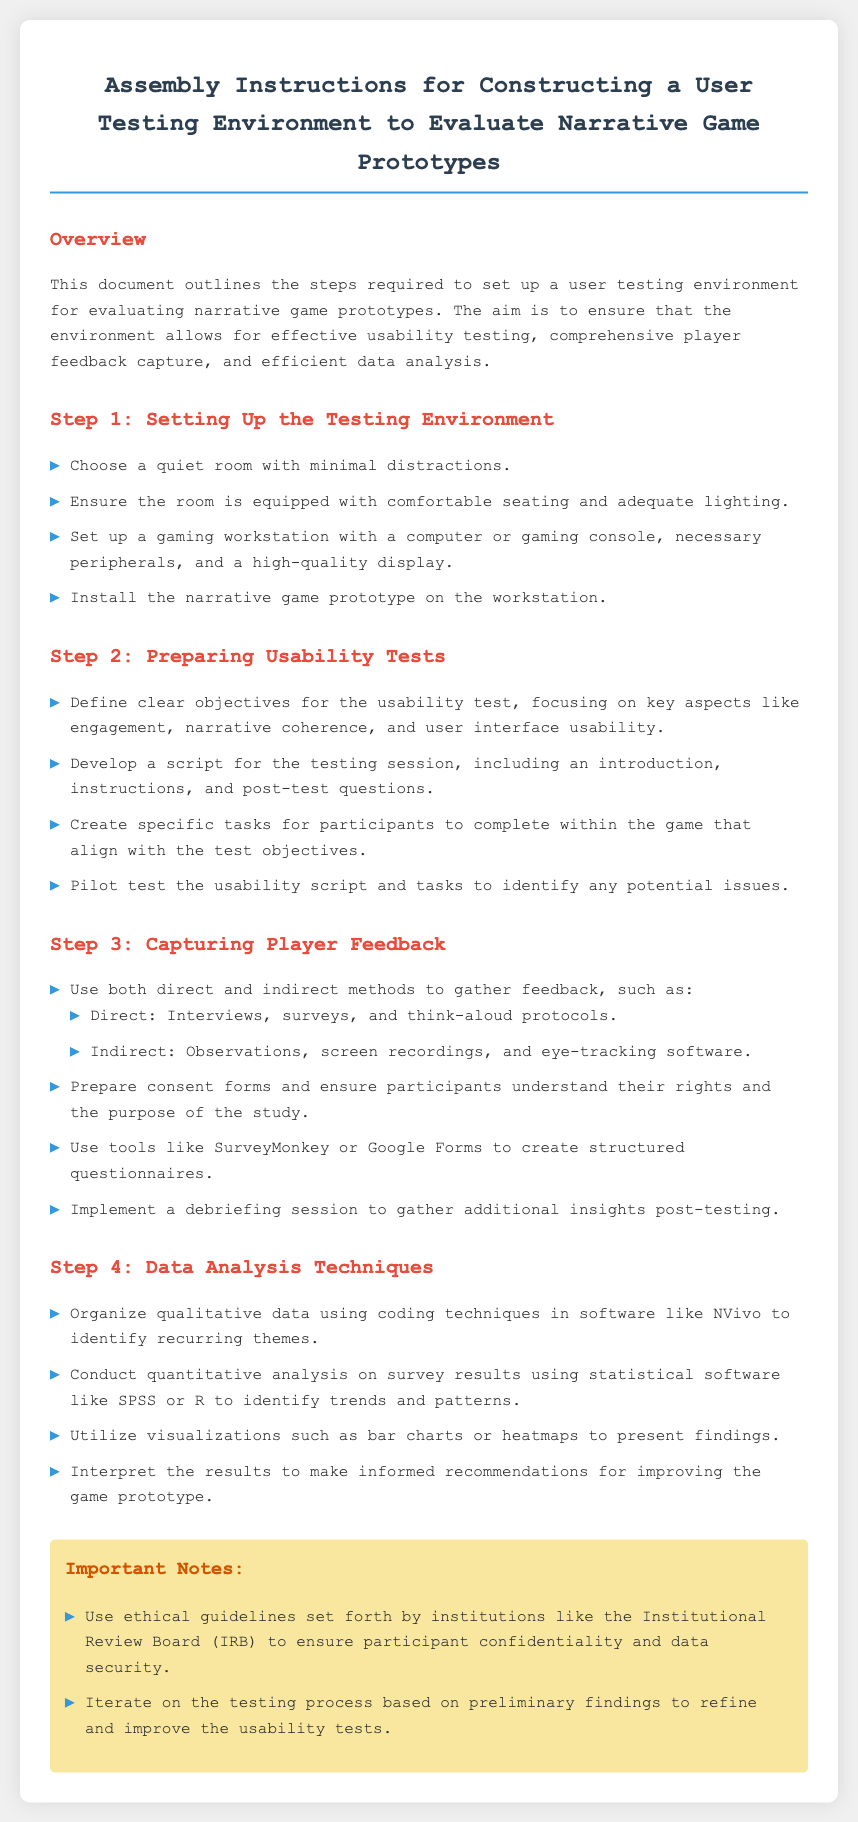What is the title of the document? The title of the document is the heading presented in the document's main section.
Answer: Assembly Instructions for Constructing a User Testing Environment to Evaluate Narrative Game Prototypes What should you ensure about the testing room? The document specifies conditions for the testing room in the "Setting Up the Testing Environment" section.
Answer: Minimal distractions What software can be used for qualitative data coding? The document mentions specific software options in the "Data Analysis Techniques" section.
Answer: NVivo What is a recommended tool for structured questionnaires? The document lists tools for gathering player feedback in the "Capturing Player Feedback" section.
Answer: SurveyMonkey What is the first step in setting up the testing environment? The document outlines steps in numbered order under "Step 1: Setting Up the Testing Environment."
Answer: Choose a quiet room What is an example of a direct method to capture feedback? The document provides examples in the "Capturing Player Feedback" section.
Answer: Interviews How should participant confidentiality be managed? Important notes in the document describe ethical guidelines relevant to the research.
Answer: Ethical guidelines What type of analysis can identify trends and patterns in survey results? The analysis techniques mentioned in the "Data Analysis Techniques" section reference specific types of analysis.
Answer: Quantitative analysis 